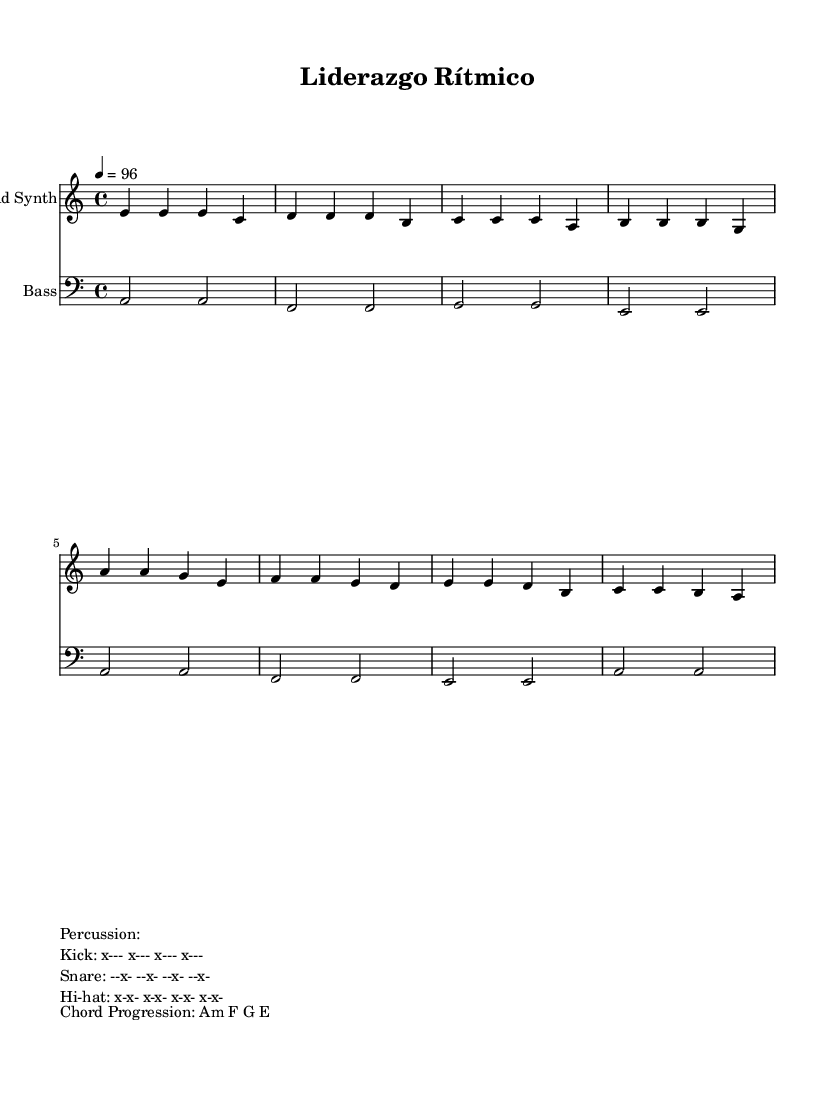What is the key signature of the music? The key signature is indicated at the beginning of the music, showing that it is A minor, which has no sharps or flats.
Answer: A minor What is the time signature of the piece? The time signature is found at the beginning of the music, showing that it is in 4/4 time, which means there are four beats in each measure.
Answer: 4/4 What is the tempo marking of the piece? The tempo marking is located above the staff and indicates a tempo of 96 beats per minute, meaning the music should be played at this speed.
Answer: 96 How many bars are in the 'Intro'? The 'Intro' consists of four measures as indicated by the vertical lines separating the musical phrases in the notation.
Answer: 4 What type of vocal style is suggested by the lyrics? The lyrics suggest a communal and teamwork style of singing, as indicated by phrases that emphasize leadership and collaboration, typical of Latin music themes.
Answer: Communal What instruments are indicated in the score? The score lists 'Lead Synth' for the lead melody and 'Bass' for the harmonic support, as noted in the labels for each staff.
Answer: Lead Synth, Bass What is the chord progression used in the music? The chord progression is given in the markup section, showing a sequence of chords that is commonly used in Latin music styles: A minor, F, G, E.
Answer: Am F G E 